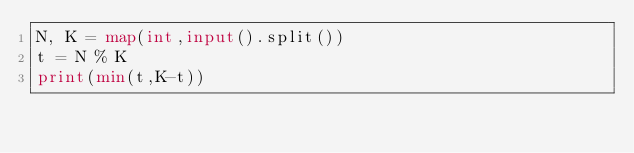<code> <loc_0><loc_0><loc_500><loc_500><_Python_>N, K = map(int,input().split())
t = N % K
print(min(t,K-t))
</code> 